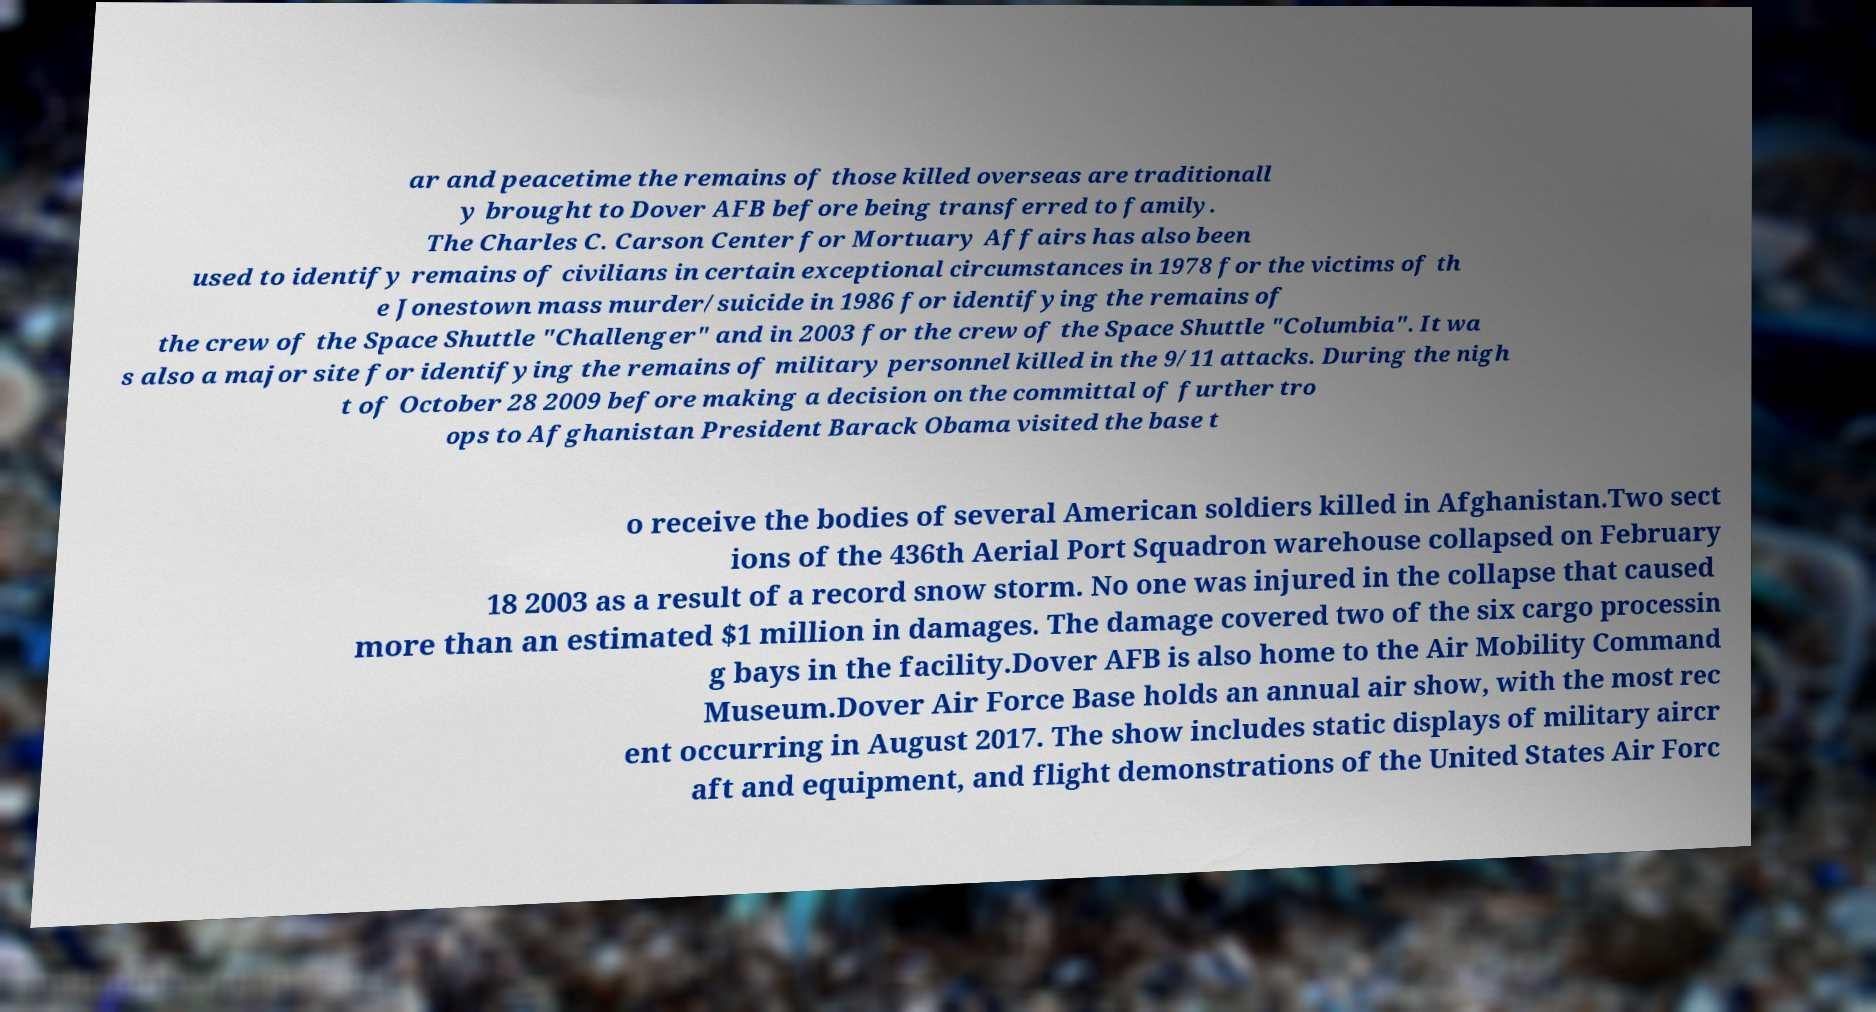Please read and relay the text visible in this image. What does it say? ar and peacetime the remains of those killed overseas are traditionall y brought to Dover AFB before being transferred to family. The Charles C. Carson Center for Mortuary Affairs has also been used to identify remains of civilians in certain exceptional circumstances in 1978 for the victims of th e Jonestown mass murder/suicide in 1986 for identifying the remains of the crew of the Space Shuttle "Challenger" and in 2003 for the crew of the Space Shuttle "Columbia". It wa s also a major site for identifying the remains of military personnel killed in the 9/11 attacks. During the nigh t of October 28 2009 before making a decision on the committal of further tro ops to Afghanistan President Barack Obama visited the base t o receive the bodies of several American soldiers killed in Afghanistan.Two sect ions of the 436th Aerial Port Squadron warehouse collapsed on February 18 2003 as a result of a record snow storm. No one was injured in the collapse that caused more than an estimated $1 million in damages. The damage covered two of the six cargo processin g bays in the facility.Dover AFB is also home to the Air Mobility Command Museum.Dover Air Force Base holds an annual air show, with the most rec ent occurring in August 2017. The show includes static displays of military aircr aft and equipment, and flight demonstrations of the United States Air Forc 